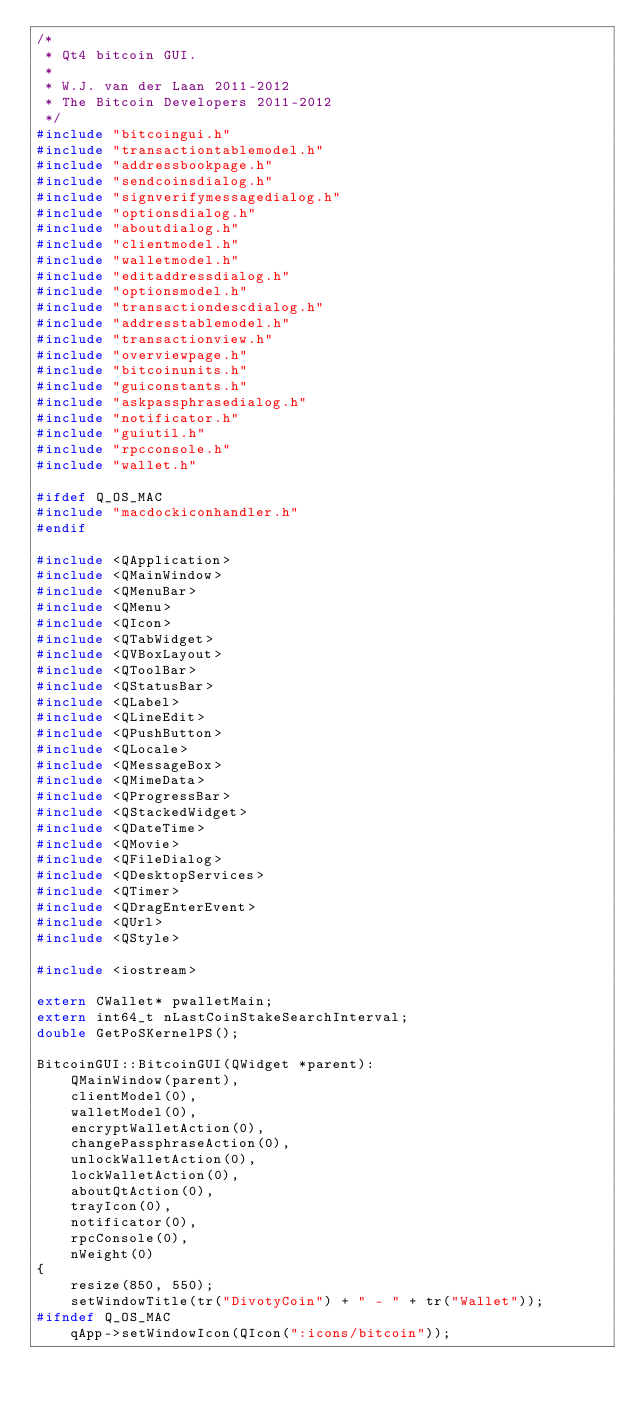Convert code to text. <code><loc_0><loc_0><loc_500><loc_500><_C++_>/*
 * Qt4 bitcoin GUI.
 *
 * W.J. van der Laan 2011-2012
 * The Bitcoin Developers 2011-2012
 */
#include "bitcoingui.h"
#include "transactiontablemodel.h"
#include "addressbookpage.h"
#include "sendcoinsdialog.h"
#include "signverifymessagedialog.h"
#include "optionsdialog.h"
#include "aboutdialog.h"
#include "clientmodel.h"
#include "walletmodel.h"
#include "editaddressdialog.h"
#include "optionsmodel.h"
#include "transactiondescdialog.h"
#include "addresstablemodel.h"
#include "transactionview.h"
#include "overviewpage.h"
#include "bitcoinunits.h"
#include "guiconstants.h"
#include "askpassphrasedialog.h"
#include "notificator.h"
#include "guiutil.h"
#include "rpcconsole.h"
#include "wallet.h"

#ifdef Q_OS_MAC
#include "macdockiconhandler.h"
#endif

#include <QApplication>
#include <QMainWindow>
#include <QMenuBar>
#include <QMenu>
#include <QIcon>
#include <QTabWidget>
#include <QVBoxLayout>
#include <QToolBar>
#include <QStatusBar>
#include <QLabel>
#include <QLineEdit>
#include <QPushButton>
#include <QLocale>
#include <QMessageBox>
#include <QMimeData>
#include <QProgressBar>
#include <QStackedWidget>
#include <QDateTime>
#include <QMovie>
#include <QFileDialog>
#include <QDesktopServices>
#include <QTimer>
#include <QDragEnterEvent>
#include <QUrl>
#include <QStyle>

#include <iostream>

extern CWallet* pwalletMain;
extern int64_t nLastCoinStakeSearchInterval;
double GetPoSKernelPS();

BitcoinGUI::BitcoinGUI(QWidget *parent):
    QMainWindow(parent),
    clientModel(0),
    walletModel(0),
    encryptWalletAction(0),
    changePassphraseAction(0),
    unlockWalletAction(0),
    lockWalletAction(0),
    aboutQtAction(0),
    trayIcon(0),
    notificator(0),
    rpcConsole(0),
    nWeight(0)
{
    resize(850, 550);
    setWindowTitle(tr("DivotyCoin") + " - " + tr("Wallet"));
#ifndef Q_OS_MAC
    qApp->setWindowIcon(QIcon(":icons/bitcoin"));</code> 